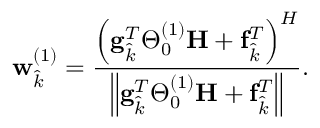<formula> <loc_0><loc_0><loc_500><loc_500>w _ { \hat { k } } ^ { ( 1 ) } = \frac { \left ( g _ { \hat { k } } ^ { T } \Theta _ { 0 } ^ { ( 1 ) } H + f _ { \hat { k } } ^ { T } \right ) ^ { H } } { \left \| g _ { \hat { k } } ^ { T } \Theta _ { 0 } ^ { ( 1 ) } H + f _ { \hat { k } } ^ { T } \right \| } .</formula> 